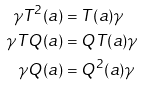<formula> <loc_0><loc_0><loc_500><loc_500>\gamma T ^ { 2 } ( a ) & = T ( a ) \gamma \\ \gamma T Q ( a ) & = Q T ( a ) \gamma \\ \gamma Q ( a ) & = Q ^ { 2 } ( a ) \gamma</formula> 